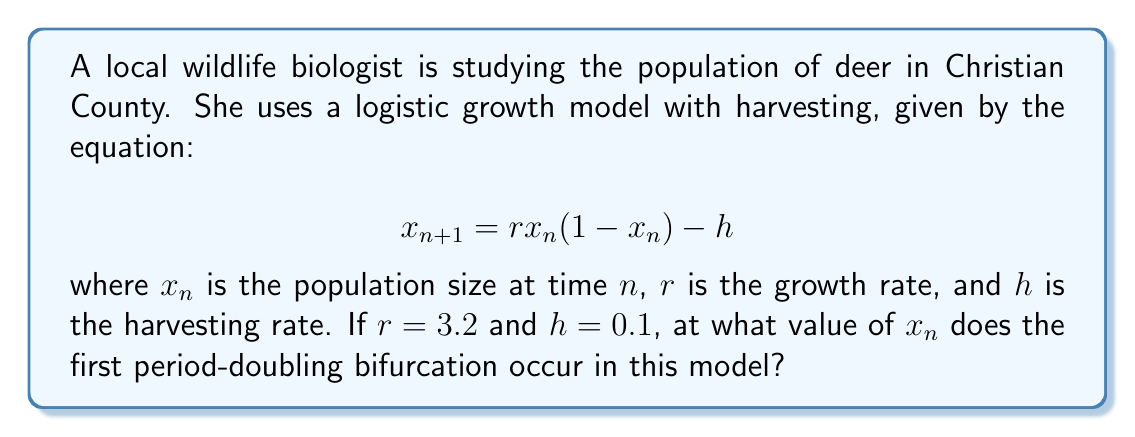Show me your answer to this math problem. To find the first period-doubling bifurcation point, we need to follow these steps:

1) First, we need to find the fixed points of the system. These occur when $x_{n+1} = x_n = x^*$. So we solve:

   $$x^* = 3.2x^*(1-x^*) - 0.1$$

2) This can be rearranged to:

   $$3.2(x^*)^2 - 3.2x^* + 0.1 = 0$$

3) Solving this quadratic equation gives us two fixed points:

   $$x^*_1 \approx 0.0323 \text{ and } x^*_2 \approx 0.9677$$

4) The period-doubling bifurcation occurs when the stability of the fixed point changes. This happens when the derivative of the function at the fixed point equals -1:

   $$f'(x^*) = r(1-2x^*) = -1$$

5) Substituting our known value of $r$:

   $$3.2(1-2x^*) = -1$$

6) Solving for $x^*$:

   $$1-2x^* = -\frac{1}{3.2}$$
   $$-2x^* = -\frac{1}{3.2} - 1 = -\frac{4.2}{3.2}$$
   $$x^* = \frac{4.2}{6.4} = \frac{21}{32} = 0.65625$$

7) This value of $x^*$ is where the first period-doubling bifurcation occurs in this model.
Answer: 0.65625 